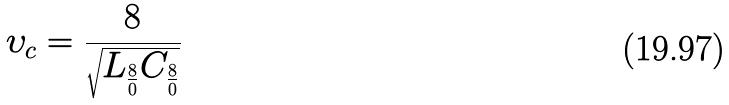<formula> <loc_0><loc_0><loc_500><loc_500>\upsilon _ { c } = \frac { 8 } { \sqrt { L _ { \frac { 8 } { 0 } } C _ { \frac { 8 } { 0 } } } }</formula> 